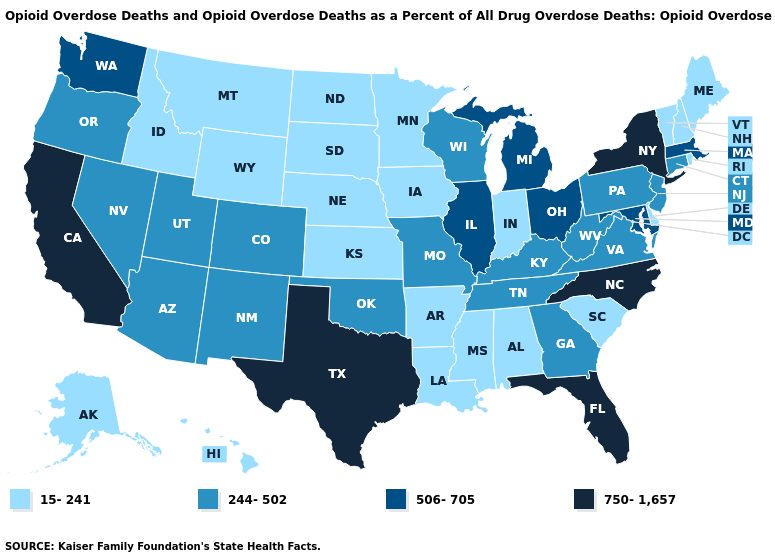Does Minnesota have the lowest value in the USA?
Give a very brief answer. Yes. Name the states that have a value in the range 506-705?
Answer briefly. Illinois, Maryland, Massachusetts, Michigan, Ohio, Washington. Name the states that have a value in the range 15-241?
Be succinct. Alabama, Alaska, Arkansas, Delaware, Hawaii, Idaho, Indiana, Iowa, Kansas, Louisiana, Maine, Minnesota, Mississippi, Montana, Nebraska, New Hampshire, North Dakota, Rhode Island, South Carolina, South Dakota, Vermont, Wyoming. Does Indiana have the lowest value in the USA?
Short answer required. Yes. What is the value of North Dakota?
Concise answer only. 15-241. Name the states that have a value in the range 15-241?
Give a very brief answer. Alabama, Alaska, Arkansas, Delaware, Hawaii, Idaho, Indiana, Iowa, Kansas, Louisiana, Maine, Minnesota, Mississippi, Montana, Nebraska, New Hampshire, North Dakota, Rhode Island, South Carolina, South Dakota, Vermont, Wyoming. Which states have the highest value in the USA?
Be succinct. California, Florida, New York, North Carolina, Texas. Does Ohio have the lowest value in the MidWest?
Write a very short answer. No. Is the legend a continuous bar?
Concise answer only. No. What is the highest value in states that border New Jersey?
Quick response, please. 750-1,657. What is the value of New Hampshire?
Short answer required. 15-241. What is the lowest value in the MidWest?
Write a very short answer. 15-241. Name the states that have a value in the range 15-241?
Give a very brief answer. Alabama, Alaska, Arkansas, Delaware, Hawaii, Idaho, Indiana, Iowa, Kansas, Louisiana, Maine, Minnesota, Mississippi, Montana, Nebraska, New Hampshire, North Dakota, Rhode Island, South Carolina, South Dakota, Vermont, Wyoming. What is the value of New Mexico?
Concise answer only. 244-502. What is the value of Nevada?
Keep it brief. 244-502. 